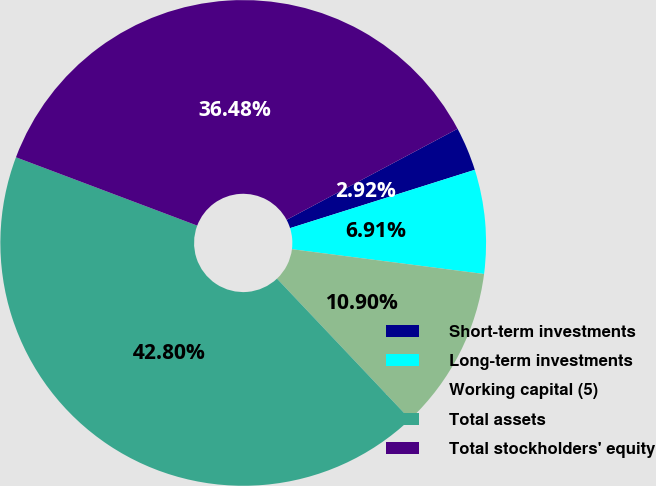<chart> <loc_0><loc_0><loc_500><loc_500><pie_chart><fcel>Short-term investments<fcel>Long-term investments<fcel>Working capital (5)<fcel>Total assets<fcel>Total stockholders' equity<nl><fcel>2.92%<fcel>6.91%<fcel>10.9%<fcel>42.8%<fcel>36.48%<nl></chart> 